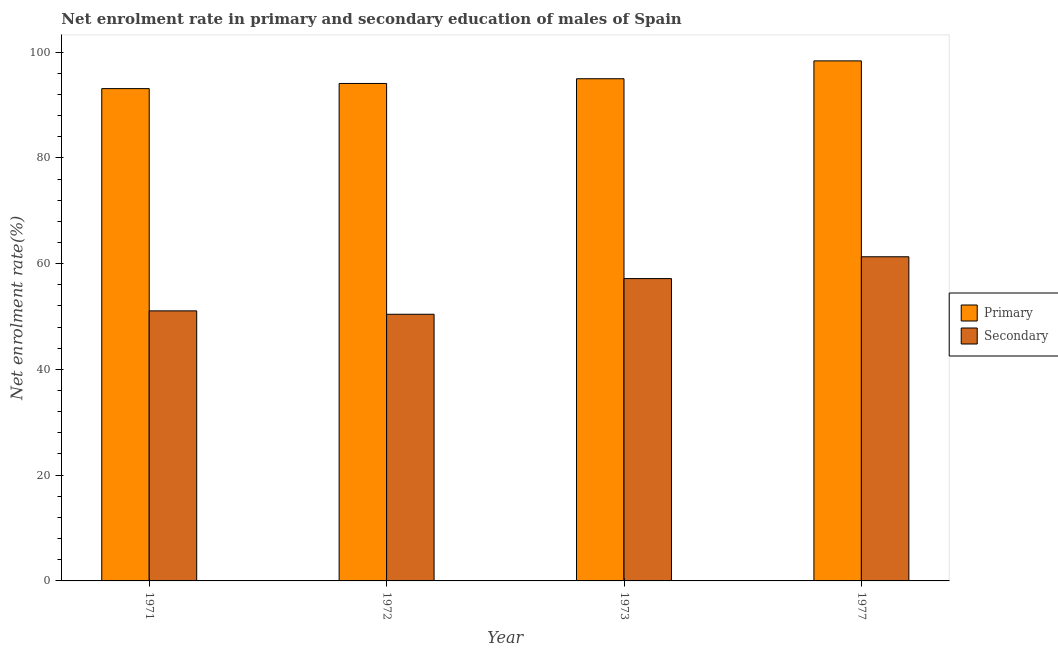How many bars are there on the 2nd tick from the left?
Make the answer very short. 2. What is the label of the 1st group of bars from the left?
Provide a short and direct response. 1971. What is the enrollment rate in primary education in 1972?
Offer a terse response. 94.07. Across all years, what is the maximum enrollment rate in primary education?
Your answer should be very brief. 98.34. Across all years, what is the minimum enrollment rate in secondary education?
Provide a short and direct response. 50.42. In which year was the enrollment rate in primary education maximum?
Your response must be concise. 1977. In which year was the enrollment rate in secondary education minimum?
Offer a terse response. 1972. What is the total enrollment rate in primary education in the graph?
Your answer should be very brief. 380.45. What is the difference between the enrollment rate in secondary education in 1972 and that in 1977?
Offer a very short reply. -10.87. What is the difference between the enrollment rate in primary education in 1971 and the enrollment rate in secondary education in 1972?
Keep it short and to the point. -0.98. What is the average enrollment rate in secondary education per year?
Provide a succinct answer. 54.99. In the year 1973, what is the difference between the enrollment rate in primary education and enrollment rate in secondary education?
Give a very brief answer. 0. What is the ratio of the enrollment rate in secondary education in 1972 to that in 1973?
Make the answer very short. 0.88. Is the enrollment rate in secondary education in 1971 less than that in 1973?
Keep it short and to the point. Yes. Is the difference between the enrollment rate in primary education in 1972 and 1973 greater than the difference between the enrollment rate in secondary education in 1972 and 1973?
Ensure brevity in your answer.  No. What is the difference between the highest and the second highest enrollment rate in primary education?
Make the answer very short. 3.38. What is the difference between the highest and the lowest enrollment rate in secondary education?
Offer a terse response. 10.87. In how many years, is the enrollment rate in secondary education greater than the average enrollment rate in secondary education taken over all years?
Provide a succinct answer. 2. What does the 2nd bar from the left in 1977 represents?
Your answer should be compact. Secondary. What does the 2nd bar from the right in 1973 represents?
Ensure brevity in your answer.  Primary. Are all the bars in the graph horizontal?
Your response must be concise. No. How many years are there in the graph?
Make the answer very short. 4. What is the difference between two consecutive major ticks on the Y-axis?
Your answer should be compact. 20. Are the values on the major ticks of Y-axis written in scientific E-notation?
Your answer should be very brief. No. Does the graph contain grids?
Give a very brief answer. No. What is the title of the graph?
Give a very brief answer. Net enrolment rate in primary and secondary education of males of Spain. What is the label or title of the X-axis?
Make the answer very short. Year. What is the label or title of the Y-axis?
Offer a very short reply. Net enrolment rate(%). What is the Net enrolment rate(%) in Primary in 1971?
Your response must be concise. 93.09. What is the Net enrolment rate(%) in Secondary in 1971?
Offer a terse response. 51.06. What is the Net enrolment rate(%) of Primary in 1972?
Give a very brief answer. 94.07. What is the Net enrolment rate(%) of Secondary in 1972?
Keep it short and to the point. 50.42. What is the Net enrolment rate(%) of Primary in 1973?
Your answer should be compact. 94.96. What is the Net enrolment rate(%) of Secondary in 1973?
Your answer should be very brief. 57.17. What is the Net enrolment rate(%) of Primary in 1977?
Make the answer very short. 98.34. What is the Net enrolment rate(%) in Secondary in 1977?
Provide a short and direct response. 61.29. Across all years, what is the maximum Net enrolment rate(%) in Primary?
Ensure brevity in your answer.  98.34. Across all years, what is the maximum Net enrolment rate(%) in Secondary?
Offer a very short reply. 61.29. Across all years, what is the minimum Net enrolment rate(%) of Primary?
Give a very brief answer. 93.09. Across all years, what is the minimum Net enrolment rate(%) in Secondary?
Your answer should be compact. 50.42. What is the total Net enrolment rate(%) in Primary in the graph?
Your response must be concise. 380.45. What is the total Net enrolment rate(%) in Secondary in the graph?
Your response must be concise. 219.95. What is the difference between the Net enrolment rate(%) in Primary in 1971 and that in 1972?
Keep it short and to the point. -0.98. What is the difference between the Net enrolment rate(%) in Secondary in 1971 and that in 1972?
Your answer should be very brief. 0.64. What is the difference between the Net enrolment rate(%) of Primary in 1971 and that in 1973?
Your answer should be very brief. -1.87. What is the difference between the Net enrolment rate(%) in Secondary in 1971 and that in 1973?
Offer a terse response. -6.11. What is the difference between the Net enrolment rate(%) of Primary in 1971 and that in 1977?
Offer a terse response. -5.25. What is the difference between the Net enrolment rate(%) in Secondary in 1971 and that in 1977?
Your answer should be very brief. -10.23. What is the difference between the Net enrolment rate(%) of Primary in 1972 and that in 1973?
Give a very brief answer. -0.89. What is the difference between the Net enrolment rate(%) in Secondary in 1972 and that in 1973?
Keep it short and to the point. -6.75. What is the difference between the Net enrolment rate(%) in Primary in 1972 and that in 1977?
Provide a succinct answer. -4.27. What is the difference between the Net enrolment rate(%) in Secondary in 1972 and that in 1977?
Your response must be concise. -10.87. What is the difference between the Net enrolment rate(%) in Primary in 1973 and that in 1977?
Give a very brief answer. -3.38. What is the difference between the Net enrolment rate(%) of Secondary in 1973 and that in 1977?
Offer a very short reply. -4.12. What is the difference between the Net enrolment rate(%) in Primary in 1971 and the Net enrolment rate(%) in Secondary in 1972?
Provide a short and direct response. 42.67. What is the difference between the Net enrolment rate(%) of Primary in 1971 and the Net enrolment rate(%) of Secondary in 1973?
Your response must be concise. 35.92. What is the difference between the Net enrolment rate(%) of Primary in 1971 and the Net enrolment rate(%) of Secondary in 1977?
Your response must be concise. 31.8. What is the difference between the Net enrolment rate(%) in Primary in 1972 and the Net enrolment rate(%) in Secondary in 1973?
Keep it short and to the point. 36.9. What is the difference between the Net enrolment rate(%) in Primary in 1972 and the Net enrolment rate(%) in Secondary in 1977?
Provide a succinct answer. 32.77. What is the difference between the Net enrolment rate(%) of Primary in 1973 and the Net enrolment rate(%) of Secondary in 1977?
Your response must be concise. 33.66. What is the average Net enrolment rate(%) in Primary per year?
Your answer should be very brief. 95.11. What is the average Net enrolment rate(%) in Secondary per year?
Provide a succinct answer. 54.99. In the year 1971, what is the difference between the Net enrolment rate(%) in Primary and Net enrolment rate(%) in Secondary?
Ensure brevity in your answer.  42.02. In the year 1972, what is the difference between the Net enrolment rate(%) of Primary and Net enrolment rate(%) of Secondary?
Provide a short and direct response. 43.65. In the year 1973, what is the difference between the Net enrolment rate(%) of Primary and Net enrolment rate(%) of Secondary?
Make the answer very short. 37.79. In the year 1977, what is the difference between the Net enrolment rate(%) in Primary and Net enrolment rate(%) in Secondary?
Offer a very short reply. 37.04. What is the ratio of the Net enrolment rate(%) of Secondary in 1971 to that in 1972?
Your response must be concise. 1.01. What is the ratio of the Net enrolment rate(%) of Primary in 1971 to that in 1973?
Make the answer very short. 0.98. What is the ratio of the Net enrolment rate(%) of Secondary in 1971 to that in 1973?
Your answer should be very brief. 0.89. What is the ratio of the Net enrolment rate(%) of Primary in 1971 to that in 1977?
Make the answer very short. 0.95. What is the ratio of the Net enrolment rate(%) of Secondary in 1971 to that in 1977?
Offer a very short reply. 0.83. What is the ratio of the Net enrolment rate(%) of Primary in 1972 to that in 1973?
Give a very brief answer. 0.99. What is the ratio of the Net enrolment rate(%) of Secondary in 1972 to that in 1973?
Your response must be concise. 0.88. What is the ratio of the Net enrolment rate(%) of Primary in 1972 to that in 1977?
Your response must be concise. 0.96. What is the ratio of the Net enrolment rate(%) of Secondary in 1972 to that in 1977?
Provide a succinct answer. 0.82. What is the ratio of the Net enrolment rate(%) of Primary in 1973 to that in 1977?
Ensure brevity in your answer.  0.97. What is the ratio of the Net enrolment rate(%) in Secondary in 1973 to that in 1977?
Your answer should be compact. 0.93. What is the difference between the highest and the second highest Net enrolment rate(%) of Primary?
Your response must be concise. 3.38. What is the difference between the highest and the second highest Net enrolment rate(%) in Secondary?
Provide a succinct answer. 4.12. What is the difference between the highest and the lowest Net enrolment rate(%) of Primary?
Your response must be concise. 5.25. What is the difference between the highest and the lowest Net enrolment rate(%) of Secondary?
Make the answer very short. 10.87. 